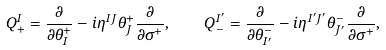Convert formula to latex. <formula><loc_0><loc_0><loc_500><loc_500>Q _ { + } ^ { I } = \frac { \partial } { \partial \theta _ { I } ^ { + } } - i \eta ^ { I J } \theta _ { J } ^ { + } \frac { \partial } { \partial \sigma ^ { + } } , \quad Q _ { - } ^ { I ^ { \prime } } = \frac { \partial } { \partial \theta _ { I ^ { \prime } } ^ { - } } - i \eta ^ { I ^ { \prime } J ^ { \prime } } \theta _ { J ^ { \prime } } ^ { - } \frac { \partial } { \partial \sigma ^ { + } } ,</formula> 